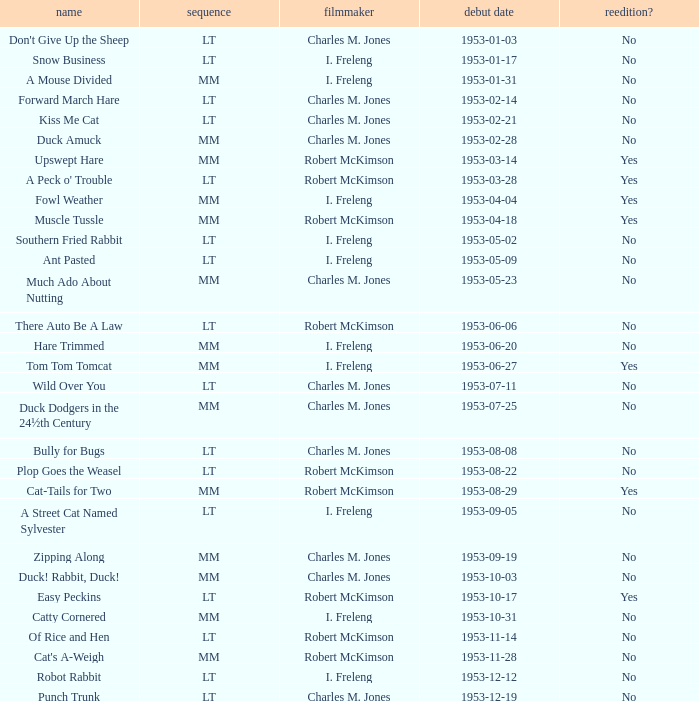Give me the full table as a dictionary. {'header': ['name', 'sequence', 'filmmaker', 'debut date', 'reedition?'], 'rows': [["Don't Give Up the Sheep", 'LT', 'Charles M. Jones', '1953-01-03', 'No'], ['Snow Business', 'LT', 'I. Freleng', '1953-01-17', 'No'], ['A Mouse Divided', 'MM', 'I. Freleng', '1953-01-31', 'No'], ['Forward March Hare', 'LT', 'Charles M. Jones', '1953-02-14', 'No'], ['Kiss Me Cat', 'LT', 'Charles M. Jones', '1953-02-21', 'No'], ['Duck Amuck', 'MM', 'Charles M. Jones', '1953-02-28', 'No'], ['Upswept Hare', 'MM', 'Robert McKimson', '1953-03-14', 'Yes'], ["A Peck o' Trouble", 'LT', 'Robert McKimson', '1953-03-28', 'Yes'], ['Fowl Weather', 'MM', 'I. Freleng', '1953-04-04', 'Yes'], ['Muscle Tussle', 'MM', 'Robert McKimson', '1953-04-18', 'Yes'], ['Southern Fried Rabbit', 'LT', 'I. Freleng', '1953-05-02', 'No'], ['Ant Pasted', 'LT', 'I. Freleng', '1953-05-09', 'No'], ['Much Ado About Nutting', 'MM', 'Charles M. Jones', '1953-05-23', 'No'], ['There Auto Be A Law', 'LT', 'Robert McKimson', '1953-06-06', 'No'], ['Hare Trimmed', 'MM', 'I. Freleng', '1953-06-20', 'No'], ['Tom Tom Tomcat', 'MM', 'I. Freleng', '1953-06-27', 'Yes'], ['Wild Over You', 'LT', 'Charles M. Jones', '1953-07-11', 'No'], ['Duck Dodgers in the 24½th Century', 'MM', 'Charles M. Jones', '1953-07-25', 'No'], ['Bully for Bugs', 'LT', 'Charles M. Jones', '1953-08-08', 'No'], ['Plop Goes the Weasel', 'LT', 'Robert McKimson', '1953-08-22', 'No'], ['Cat-Tails for Two', 'MM', 'Robert McKimson', '1953-08-29', 'Yes'], ['A Street Cat Named Sylvester', 'LT', 'I. Freleng', '1953-09-05', 'No'], ['Zipping Along', 'MM', 'Charles M. Jones', '1953-09-19', 'No'], ['Duck! Rabbit, Duck!', 'MM', 'Charles M. Jones', '1953-10-03', 'No'], ['Easy Peckins', 'LT', 'Robert McKimson', '1953-10-17', 'Yes'], ['Catty Cornered', 'MM', 'I. Freleng', '1953-10-31', 'No'], ['Of Rice and Hen', 'LT', 'Robert McKimson', '1953-11-14', 'No'], ["Cat's A-Weigh", 'MM', 'Robert McKimson', '1953-11-28', 'No'], ['Robot Rabbit', 'LT', 'I. Freleng', '1953-12-12', 'No'], ['Punch Trunk', 'LT', 'Charles M. Jones', '1953-12-19', 'No']]} What's the release date of Forward March Hare? 1953-02-14. 